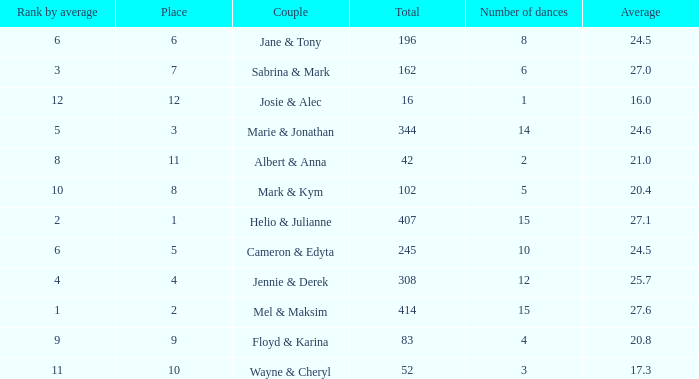Could you parse the entire table as a dict? {'header': ['Rank by average', 'Place', 'Couple', 'Total', 'Number of dances', 'Average'], 'rows': [['6', '6', 'Jane & Tony', '196', '8', '24.5'], ['3', '7', 'Sabrina & Mark', '162', '6', '27.0'], ['12', '12', 'Josie & Alec', '16', '1', '16.0'], ['5', '3', 'Marie & Jonathan', '344', '14', '24.6'], ['8', '11', 'Albert & Anna', '42', '2', '21.0'], ['10', '8', 'Mark & Kym', '102', '5', '20.4'], ['2', '1', 'Helio & Julianne', '407', '15', '27.1'], ['6', '5', 'Cameron & Edyta', '245', '10', '24.5'], ['4', '4', 'Jennie & Derek', '308', '12', '25.7'], ['1', '2', 'Mel & Maksim', '414', '15', '27.6'], ['9', '9', 'Floyd & Karina', '83', '4', '20.8'], ['11', '10', 'Wayne & Cheryl', '52', '3', '17.3']]} What is the rank by average where the total was larger than 245 and the average was 27.1 with fewer than 15 dances? None. 